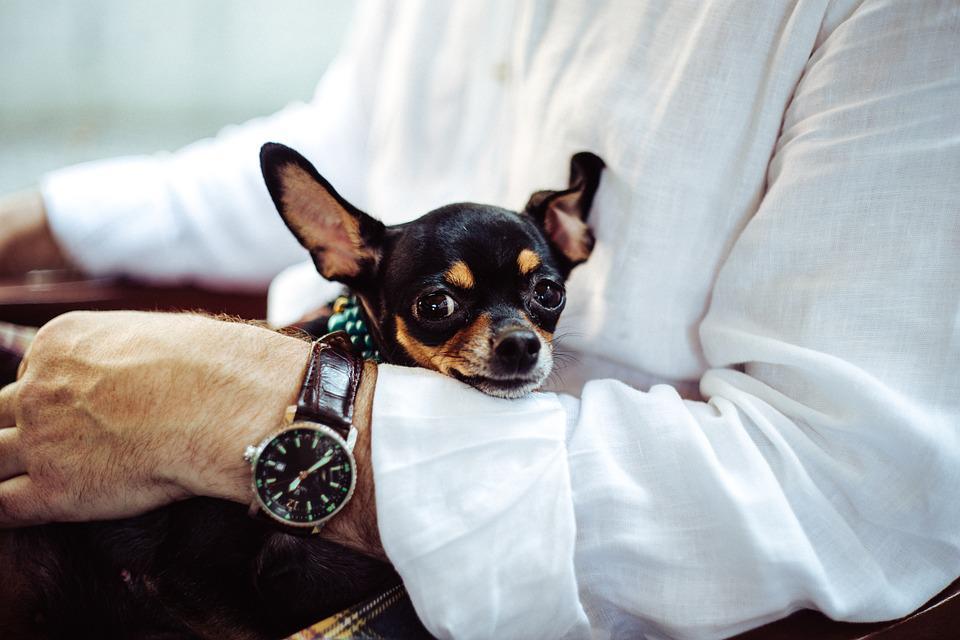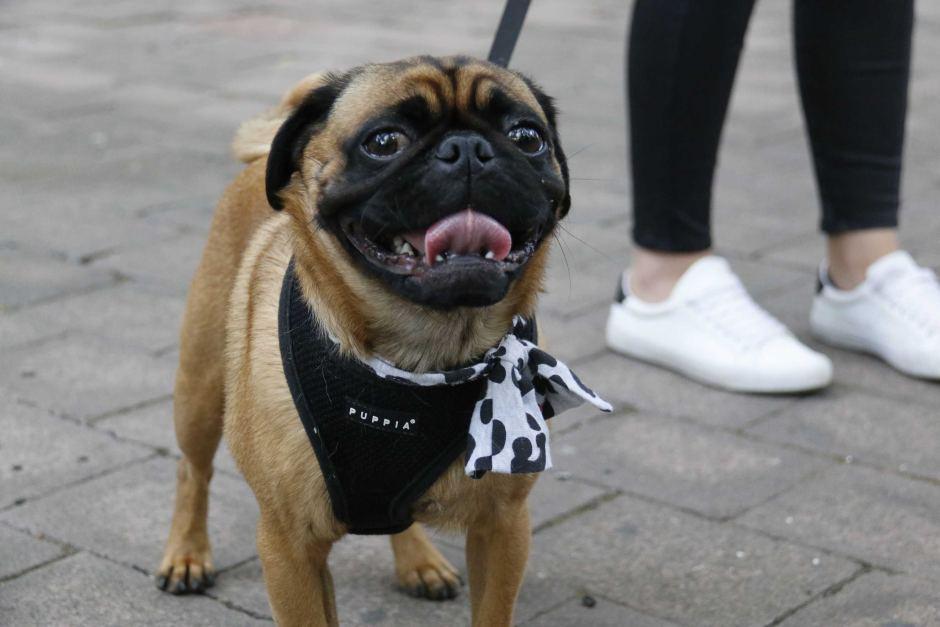The first image is the image on the left, the second image is the image on the right. Examine the images to the left and right. Is the description "One image shows a dog on a leash and the other shows a dog by white fabric." accurate? Answer yes or no. Yes. 